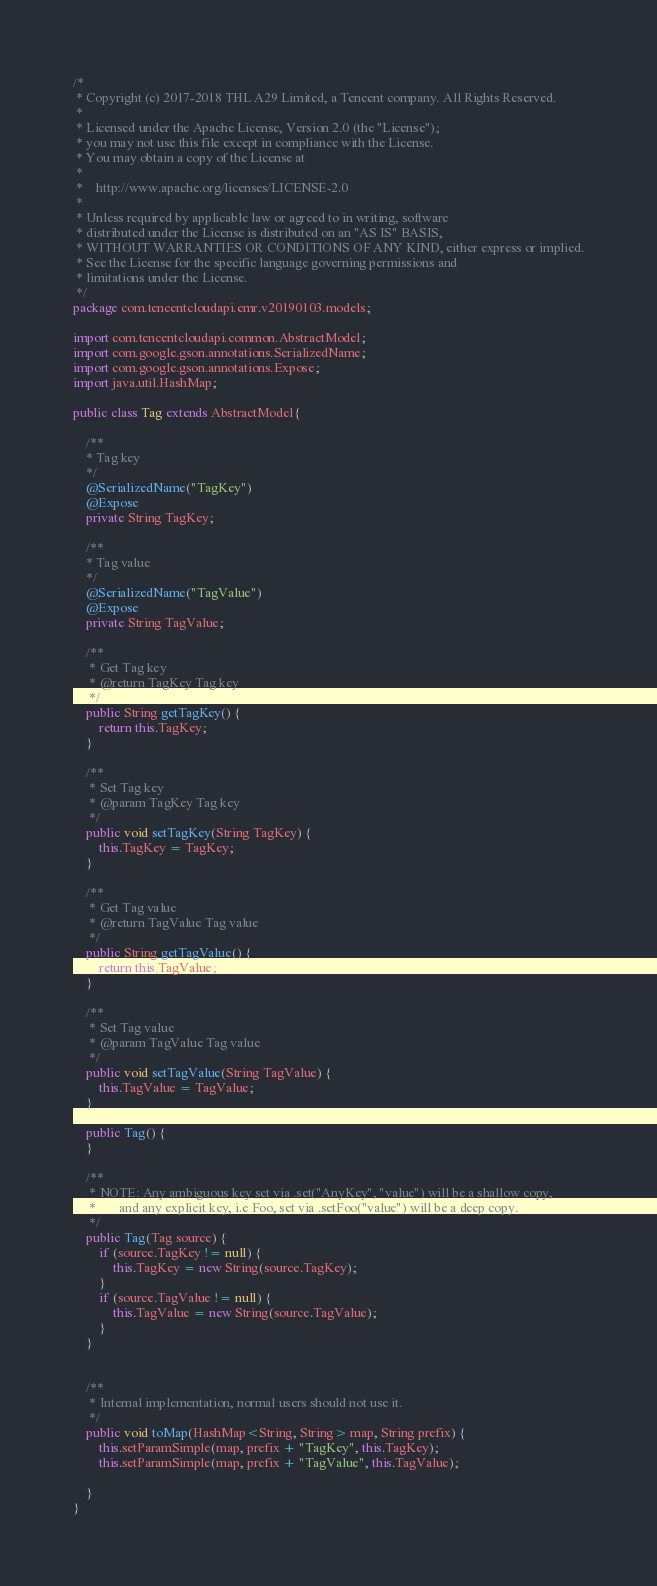<code> <loc_0><loc_0><loc_500><loc_500><_Java_>/*
 * Copyright (c) 2017-2018 THL A29 Limited, a Tencent company. All Rights Reserved.
 *
 * Licensed under the Apache License, Version 2.0 (the "License");
 * you may not use this file except in compliance with the License.
 * You may obtain a copy of the License at
 *
 *    http://www.apache.org/licenses/LICENSE-2.0
 *
 * Unless required by applicable law or agreed to in writing, software
 * distributed under the License is distributed on an "AS IS" BASIS,
 * WITHOUT WARRANTIES OR CONDITIONS OF ANY KIND, either express or implied.
 * See the License for the specific language governing permissions and
 * limitations under the License.
 */
package com.tencentcloudapi.emr.v20190103.models;

import com.tencentcloudapi.common.AbstractModel;
import com.google.gson.annotations.SerializedName;
import com.google.gson.annotations.Expose;
import java.util.HashMap;

public class Tag extends AbstractModel{

    /**
    * Tag key
    */
    @SerializedName("TagKey")
    @Expose
    private String TagKey;

    /**
    * Tag value
    */
    @SerializedName("TagValue")
    @Expose
    private String TagValue;

    /**
     * Get Tag key 
     * @return TagKey Tag key
     */
    public String getTagKey() {
        return this.TagKey;
    }

    /**
     * Set Tag key
     * @param TagKey Tag key
     */
    public void setTagKey(String TagKey) {
        this.TagKey = TagKey;
    }

    /**
     * Get Tag value 
     * @return TagValue Tag value
     */
    public String getTagValue() {
        return this.TagValue;
    }

    /**
     * Set Tag value
     * @param TagValue Tag value
     */
    public void setTagValue(String TagValue) {
        this.TagValue = TagValue;
    }

    public Tag() {
    }

    /**
     * NOTE: Any ambiguous key set via .set("AnyKey", "value") will be a shallow copy,
     *       and any explicit key, i.e Foo, set via .setFoo("value") will be a deep copy.
     */
    public Tag(Tag source) {
        if (source.TagKey != null) {
            this.TagKey = new String(source.TagKey);
        }
        if (source.TagValue != null) {
            this.TagValue = new String(source.TagValue);
        }
    }


    /**
     * Internal implementation, normal users should not use it.
     */
    public void toMap(HashMap<String, String> map, String prefix) {
        this.setParamSimple(map, prefix + "TagKey", this.TagKey);
        this.setParamSimple(map, prefix + "TagValue", this.TagValue);

    }
}

</code> 